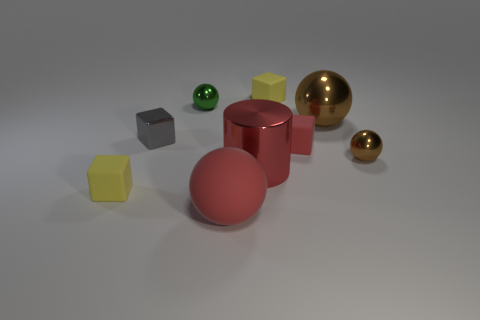Subtract all tiny green metallic balls. How many balls are left? 3 Add 1 big metallic things. How many objects exist? 10 Subtract all red spheres. How many spheres are left? 3 Subtract all cylinders. How many objects are left? 8 Subtract 1 spheres. How many spheres are left? 3 Subtract all red cubes. Subtract all small red rubber things. How many objects are left? 7 Add 6 cubes. How many cubes are left? 10 Add 7 big red rubber balls. How many big red rubber balls exist? 8 Subtract 1 gray cubes. How many objects are left? 8 Subtract all purple cubes. Subtract all blue spheres. How many cubes are left? 4 